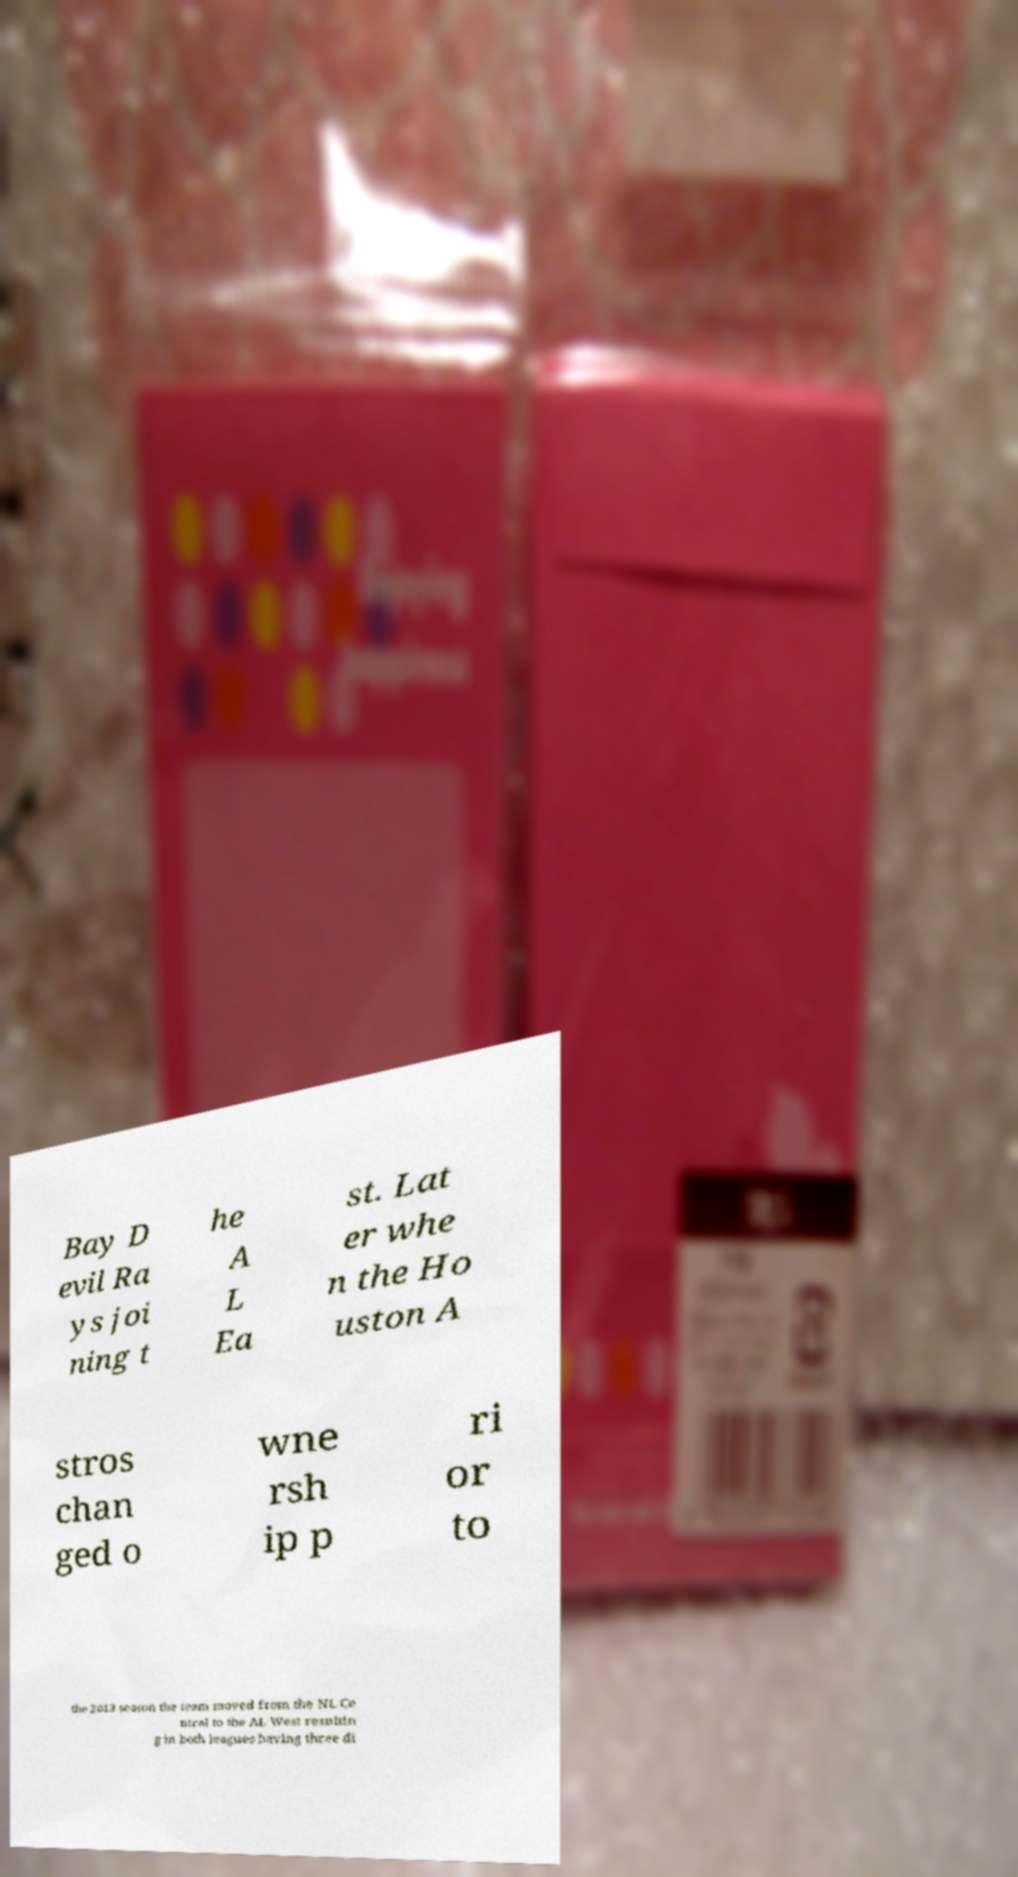There's text embedded in this image that I need extracted. Can you transcribe it verbatim? Bay D evil Ra ys joi ning t he A L Ea st. Lat er whe n the Ho uston A stros chan ged o wne rsh ip p ri or to the 2013 season the team moved from the NL Ce ntral to the AL West resultin g in both leagues having three di 